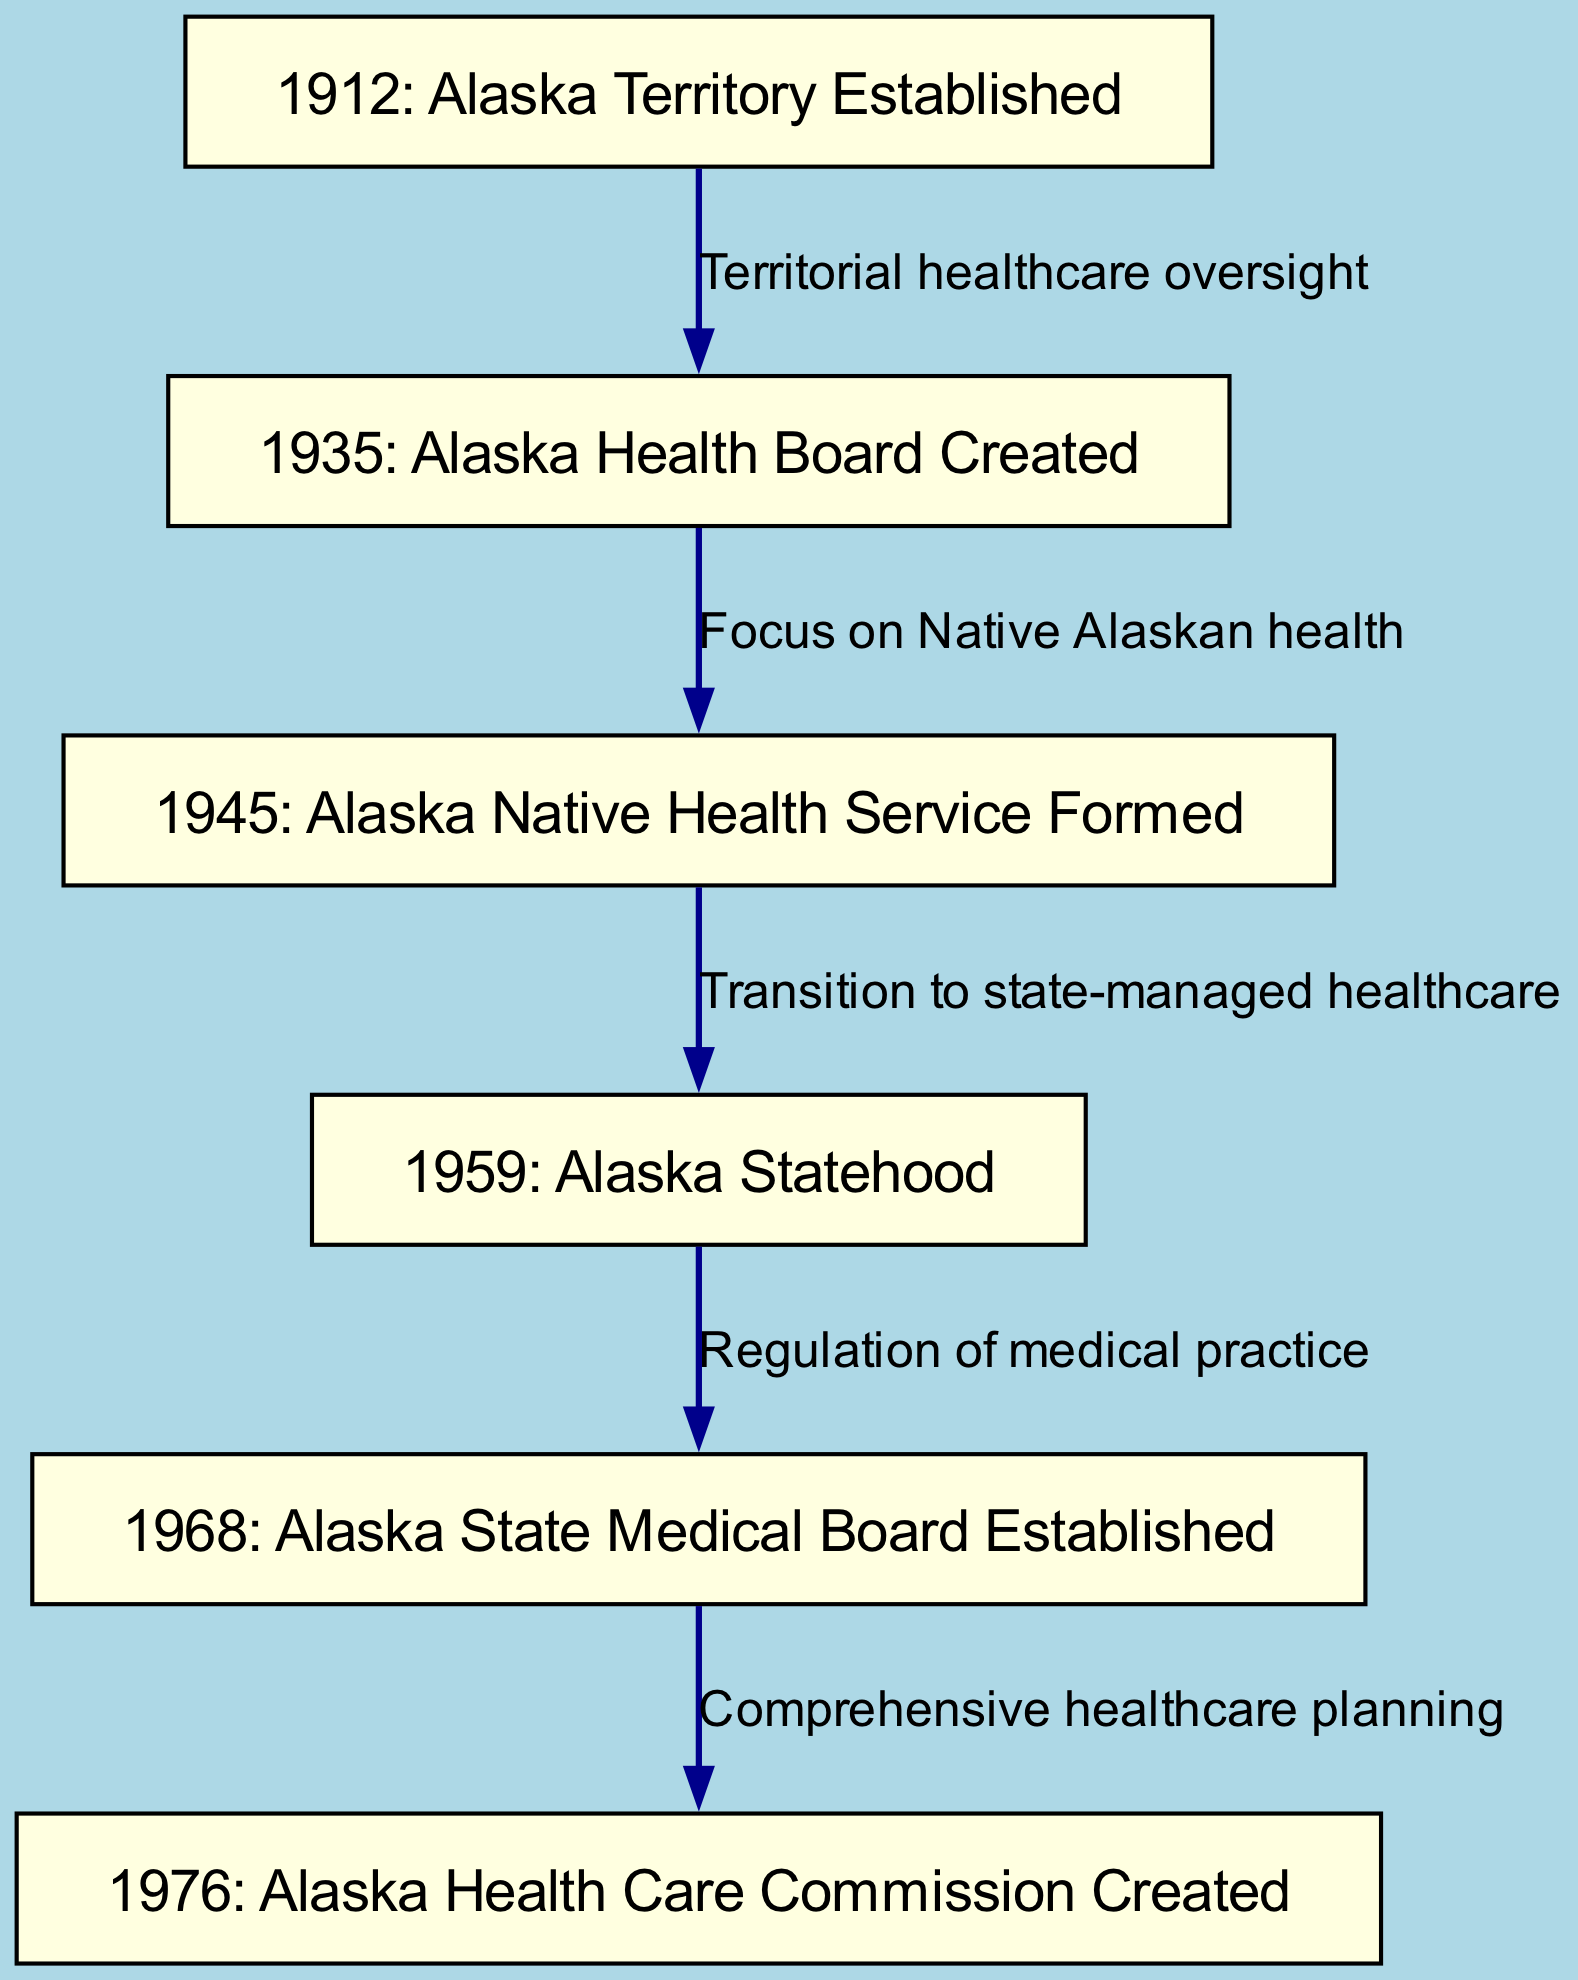What year was the Alaska Territory Established? The diagram indicates the first node labeled "1912: Alaska Territory Established", which specifically states the year of establishment.
Answer: 1912 What is the focus of the Alaska Health Board created in 1935? The edge from node "2" to node "3" is labeled "Focus on Native Alaskan health", indicating the primary focus of the Alaska Health Board.
Answer: Native Alaskan health How many nodes are present in the diagram? The diagram lists 6 distinct nodes that represent events or milestones in Alaska’s healthcare policy.
Answer: 6 What is the relationship between Alaska Statehood and the Alaska State Medical Board? The edge from node "4" to node "5" is labeled "Regulation of medical practice", showing that statehood led to the establishment of regulatory frameworks for medical practices.
Answer: Regulation of medical practice What significant service was formed in 1945? The node labeled "1945: Alaska Native Health Service Formed" directly identifies the formation of the service in that year.
Answer: Alaska Native Health Service What was established in 1976 as part of healthcare planning? The node labeled "1976: Alaska Health Care Commission Created" indicates the establishment aimed at comprehensive planning in healthcare.
Answer: Alaska Health Care Commission How does the formation of the Alaska Native Health Service relate to state-managed healthcare? The edge from node "3" to node "4" indicates a transition from service-focused care for Native Alaskans to a broader state-managed healthcare system post-statehood.
Answer: Transition to state-managed healthcare In what year was the Alaska Health Care Commission created? The diagram specifies that the commission was created in 1976, as indicated on the corresponding node.
Answer: 1976 What was the significance of the 1959 event concerning healthcare? The transition labeled between node "3" and node "4" reflects a critical shift as Alaska moved from territorial to state management of healthcare, highlighting the significance of statehood.
Answer: Transition to state-managed healthcare 